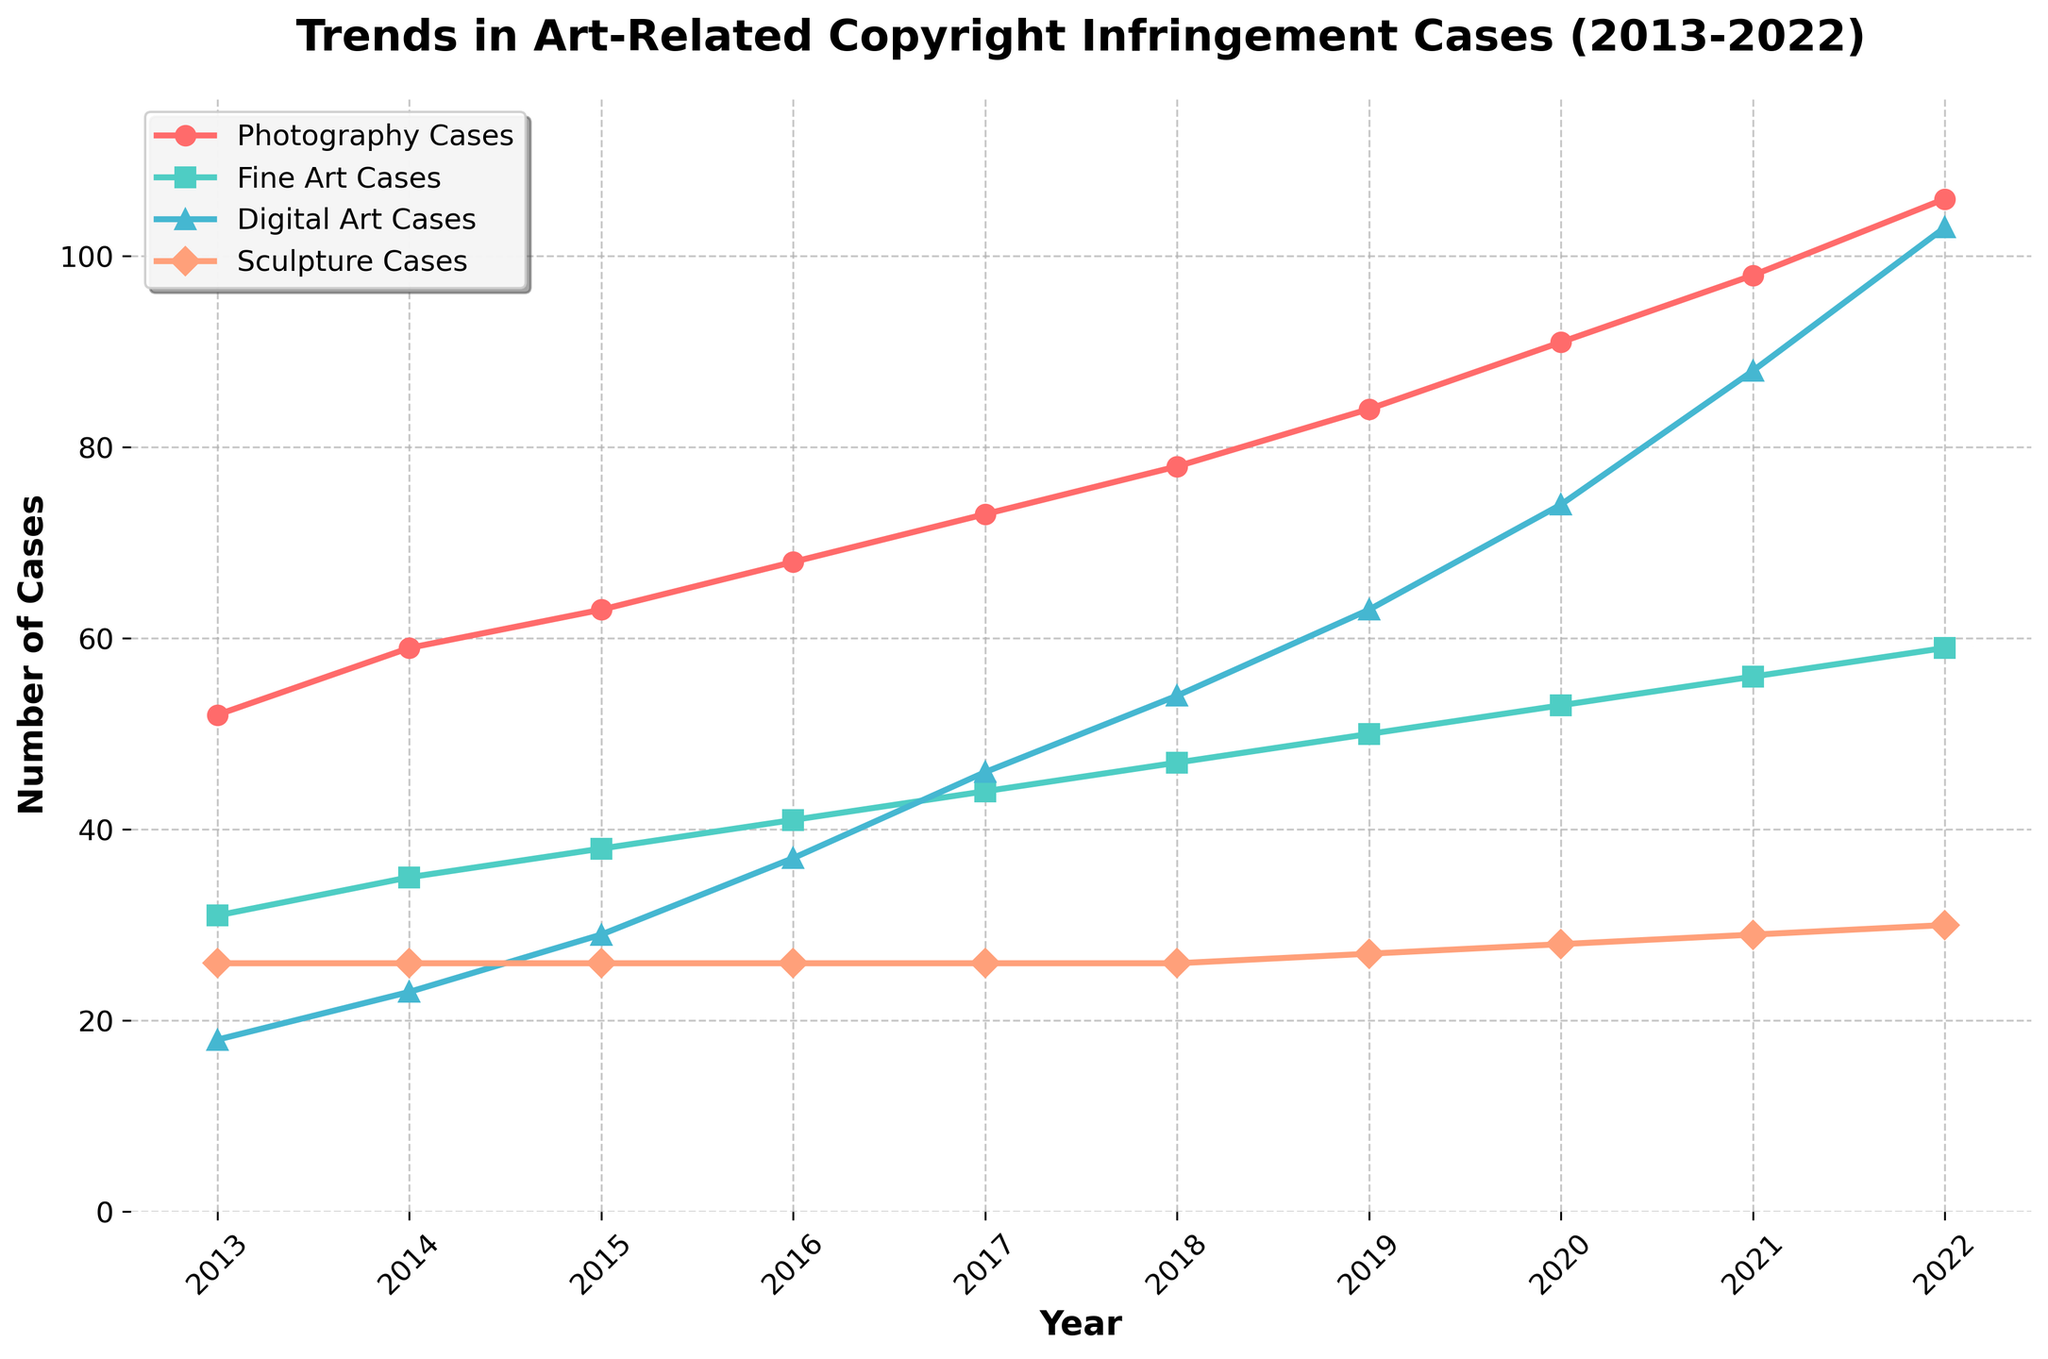What is the total number of copyright infringement cases for Fine Art in the year 2020? First, locate the yellow line (Fine Art Cases) and then find the corresponding data point for the year 2020. The value next to the marker must be read.
Answer: 53 What is the difference between the number of Photography Cases and Digital Art Cases in 2022? First, locate the data points for Photography Cases and Digital Art Cases in 2022. Photography Cases are 106 and Digital Art Cases are 103. Subtract the latter value from the former: 106 - 103 = 3.
Answer: 3 Which type of art-related copyright infringement case had the highest increase from 2013 to 2022? Compare the increases for all categories by looking at values from 2013 and 2022. Photography increased from 52 to 106 (54), Fine Art from 31 to 59 (28), Digital Art from 18 to 103 (85), and Sculpture from 26 to 30 (4). Digital Art had the highest increase.
Answer: Digital Art What is the overall trend in the number of total art-related copyright infringement cases from 2013 to 2022? Observe the trend of the overall number of cases across the years. The total number of cases consistently increases every year from 127 in 2013 to 298 in 2022.
Answer: Increasing How many more Digital Art Cases were there in 2021 compared to 2019? Digital Art Cases in 2021 were 88, and in 2019 it was 63. The increase is calculated by 88 - 63 = 25.
Answer: 25 Compare the total number of Fine Art and Sculpture Cases in 2017. Which has more? Fine Art Cases in 2017 were 44 while Sculpture Cases were 26. Compare the two values and note that the Fine Art Cases is greater.
Answer: Fine Art Cases Which category had a consistent number of cases every year from 2013 to 2017? Look for a horizontal line in the trend. Sculpture Cases remained flat at 26 from 2013 to 2017.
Answer: Sculpture Cases What is the average number of Photography Cases per year over the decade? Sum the yearly numbers for Photography Cases (52+59+63+68+73+78+84+91+98+106) = 772. Divide by the number of years (10): 772/10 = 77.2.
Answer: 77.2 In what year did Digital Art Cases surpass Fine Art Cases? Observe the point where the Digital Art and Fine Art lines cross. Digital Art overtakes Fine Art in 2016, where Digital Art has 37 and Fine Art has 41.
Answer: 2016 